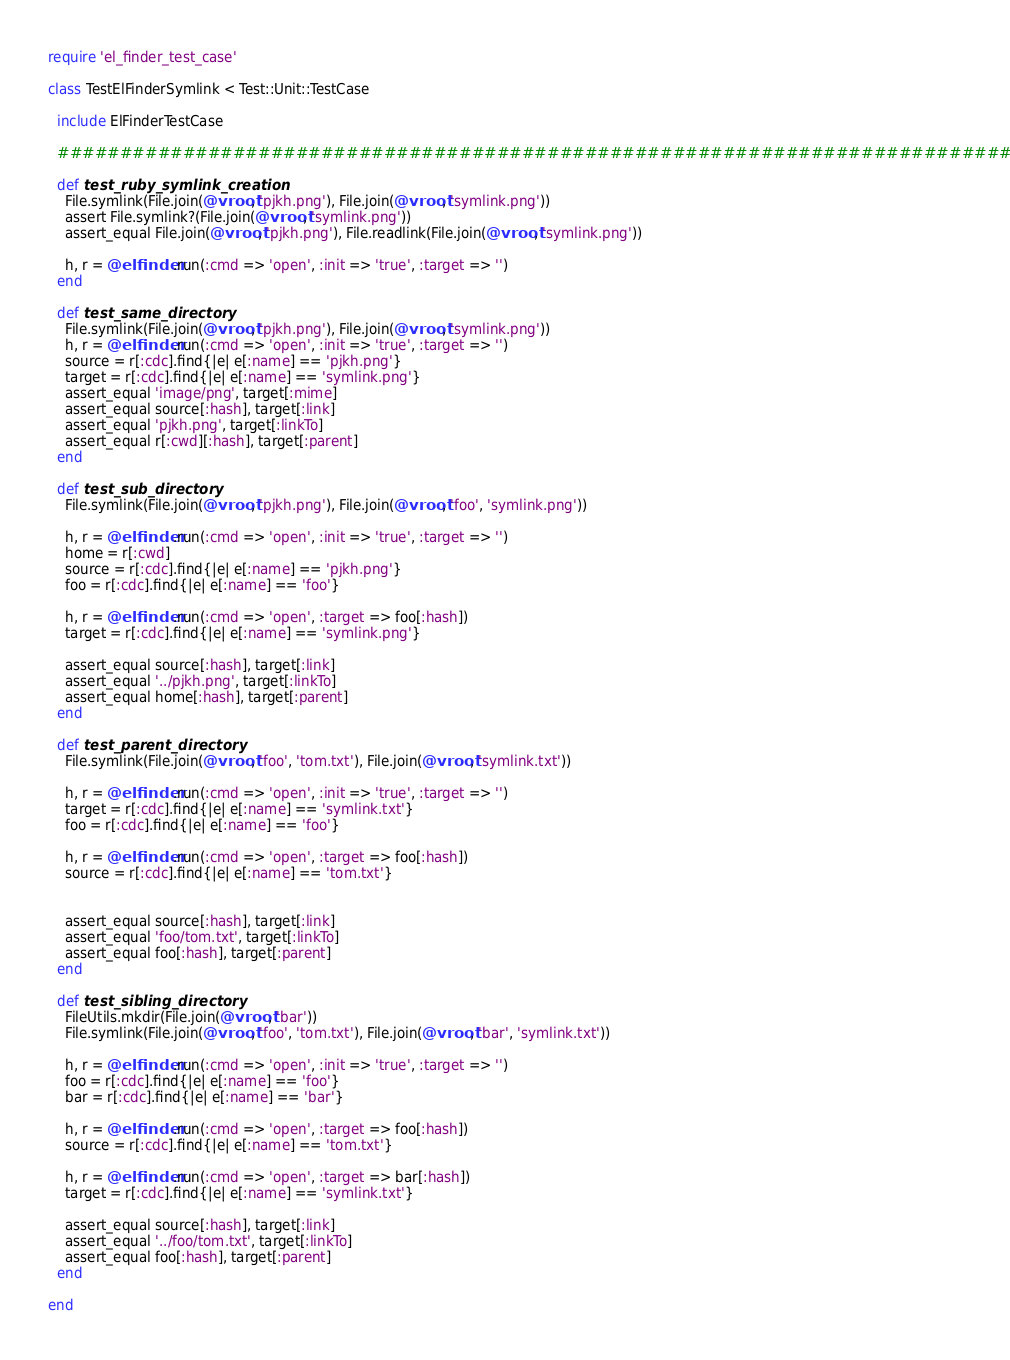Convert code to text. <code><loc_0><loc_0><loc_500><loc_500><_Ruby_>require 'el_finder_test_case'

class TestElFinderSymlink < Test::Unit::TestCase

  include ElFinderTestCase

  ################################################################################

  def test_ruby_symlink_creation
    File.symlink(File.join(@vroot, 'pjkh.png'), File.join(@vroot, 'symlink.png'))
    assert File.symlink?(File.join(@vroot, 'symlink.png'))
    assert_equal File.join(@vroot, 'pjkh.png'), File.readlink(File.join(@vroot, 'symlink.png'))

    h, r = @elfinder.run(:cmd => 'open', :init => 'true', :target => '')
  end

  def test_same_directory
    File.symlink(File.join(@vroot, 'pjkh.png'), File.join(@vroot, 'symlink.png'))
    h, r = @elfinder.run(:cmd => 'open', :init => 'true', :target => '')
    source = r[:cdc].find{|e| e[:name] == 'pjkh.png'}
    target = r[:cdc].find{|e| e[:name] == 'symlink.png'}
    assert_equal 'image/png', target[:mime]
    assert_equal source[:hash], target[:link]
    assert_equal 'pjkh.png', target[:linkTo]
    assert_equal r[:cwd][:hash], target[:parent]
  end

  def test_sub_directory
    File.symlink(File.join(@vroot, 'pjkh.png'), File.join(@vroot, 'foo', 'symlink.png'))

    h, r = @elfinder.run(:cmd => 'open', :init => 'true', :target => '')
    home = r[:cwd]
    source = r[:cdc].find{|e| e[:name] == 'pjkh.png'}
    foo = r[:cdc].find{|e| e[:name] == 'foo'}

    h, r = @elfinder.run(:cmd => 'open', :target => foo[:hash])
    target = r[:cdc].find{|e| e[:name] == 'symlink.png'}

    assert_equal source[:hash], target[:link]
    assert_equal '../pjkh.png', target[:linkTo]
    assert_equal home[:hash], target[:parent]
  end

  def test_parent_directory
    File.symlink(File.join(@vroot, 'foo', 'tom.txt'), File.join(@vroot, 'symlink.txt'))

    h, r = @elfinder.run(:cmd => 'open', :init => 'true', :target => '')
    target = r[:cdc].find{|e| e[:name] == 'symlink.txt'}
    foo = r[:cdc].find{|e| e[:name] == 'foo'}

    h, r = @elfinder.run(:cmd => 'open', :target => foo[:hash])
    source = r[:cdc].find{|e| e[:name] == 'tom.txt'}


    assert_equal source[:hash], target[:link]
    assert_equal 'foo/tom.txt', target[:linkTo]
    assert_equal foo[:hash], target[:parent]
  end

  def test_sibling_directory
    FileUtils.mkdir(File.join(@vroot, 'bar'))
    File.symlink(File.join(@vroot, 'foo', 'tom.txt'), File.join(@vroot, 'bar', 'symlink.txt'))

    h, r = @elfinder.run(:cmd => 'open', :init => 'true', :target => '')
    foo = r[:cdc].find{|e| e[:name] == 'foo'}
    bar = r[:cdc].find{|e| e[:name] == 'bar'}

    h, r = @elfinder.run(:cmd => 'open', :target => foo[:hash])
    source = r[:cdc].find{|e| e[:name] == 'tom.txt'}

    h, r = @elfinder.run(:cmd => 'open', :target => bar[:hash])
    target = r[:cdc].find{|e| e[:name] == 'symlink.txt'}

    assert_equal source[:hash], target[:link]
    assert_equal '../foo/tom.txt', target[:linkTo]
    assert_equal foo[:hash], target[:parent]
  end

end
</code> 